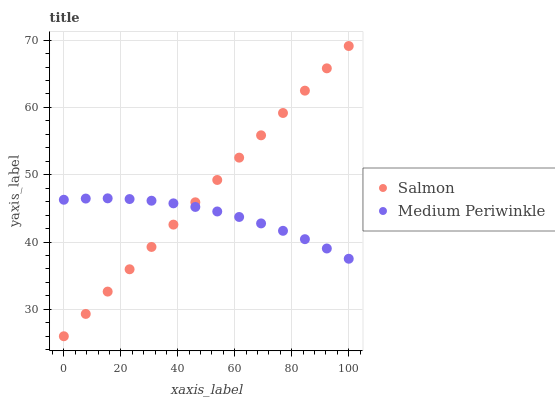Does Medium Periwinkle have the minimum area under the curve?
Answer yes or no. Yes. Does Salmon have the maximum area under the curve?
Answer yes or no. Yes. Does Salmon have the minimum area under the curve?
Answer yes or no. No. Is Salmon the smoothest?
Answer yes or no. Yes. Is Medium Periwinkle the roughest?
Answer yes or no. Yes. Is Salmon the roughest?
Answer yes or no. No. Does Salmon have the lowest value?
Answer yes or no. Yes. Does Salmon have the highest value?
Answer yes or no. Yes. Does Salmon intersect Medium Periwinkle?
Answer yes or no. Yes. Is Salmon less than Medium Periwinkle?
Answer yes or no. No. Is Salmon greater than Medium Periwinkle?
Answer yes or no. No. 